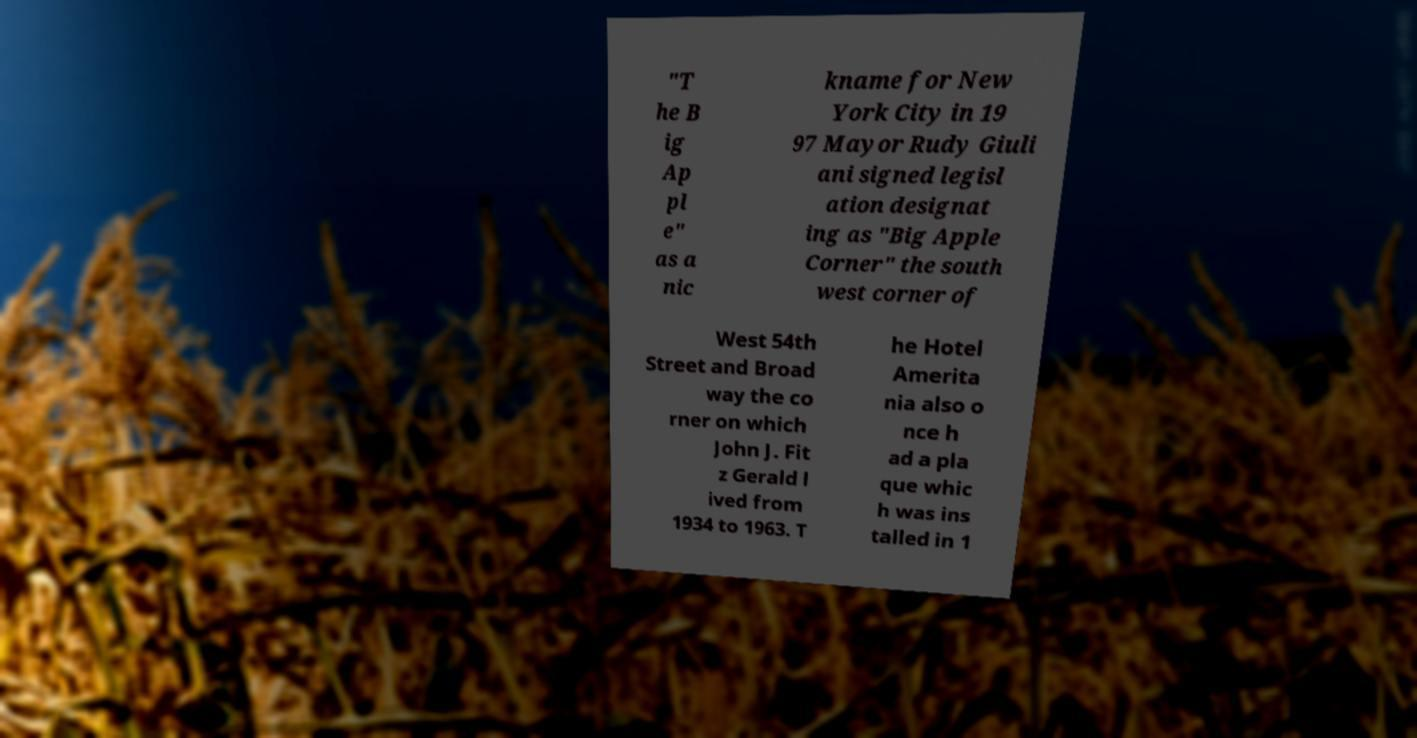Please identify and transcribe the text found in this image. "T he B ig Ap pl e" as a nic kname for New York City in 19 97 Mayor Rudy Giuli ani signed legisl ation designat ing as "Big Apple Corner" the south west corner of West 54th Street and Broad way the co rner on which John J. Fit z Gerald l ived from 1934 to 1963. T he Hotel Amerita nia also o nce h ad a pla que whic h was ins talled in 1 